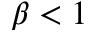<formula> <loc_0><loc_0><loc_500><loc_500>\beta < 1</formula> 